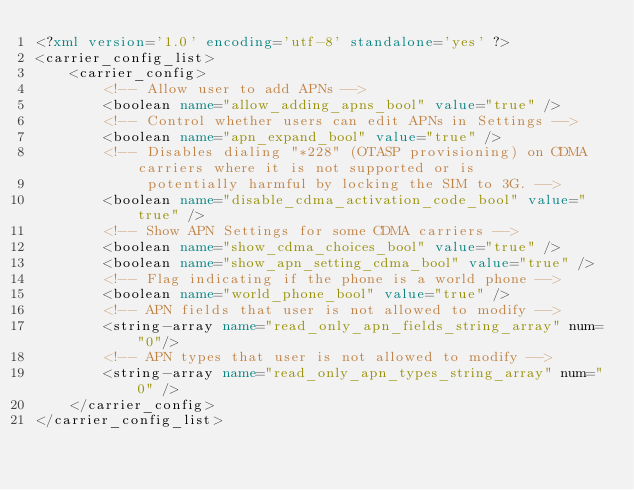Convert code to text. <code><loc_0><loc_0><loc_500><loc_500><_XML_><?xml version='1.0' encoding='utf-8' standalone='yes' ?>
<carrier_config_list>
    <carrier_config>
        <!-- Allow user to add APNs -->
        <boolean name="allow_adding_apns_bool" value="true" />
        <!-- Control whether users can edit APNs in Settings -->
        <boolean name="apn_expand_bool" value="true" />
        <!-- Disables dialing "*228" (OTASP provisioning) on CDMA carriers where it is not supported or is
             potentially harmful by locking the SIM to 3G. -->
        <boolean name="disable_cdma_activation_code_bool" value="true" />
        <!-- Show APN Settings for some CDMA carriers -->
        <boolean name="show_cdma_choices_bool" value="true" />
        <boolean name="show_apn_setting_cdma_bool" value="true" />
        <!-- Flag indicating if the phone is a world phone -->
        <boolean name="world_phone_bool" value="true" />
        <!-- APN fields that user is not allowed to modify -->
        <string-array name="read_only_apn_fields_string_array" num="0"/>
        <!-- APN types that user is not allowed to modify -->
        <string-array name="read_only_apn_types_string_array" num="0" />
    </carrier_config>
</carrier_config_list>
</code> 